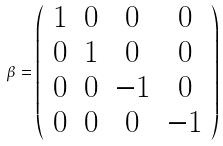<formula> <loc_0><loc_0><loc_500><loc_500>\beta = \left ( \begin{array} { c c c c } 1 & 0 & 0 & 0 \\ 0 & 1 & 0 & 0 \\ 0 & 0 & - 1 & 0 \\ 0 & 0 & 0 & - 1 \end{array} \right )</formula> 